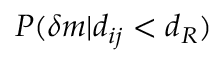Convert formula to latex. <formula><loc_0><loc_0><loc_500><loc_500>P ( \delta m | d _ { i j } < d _ { R } )</formula> 